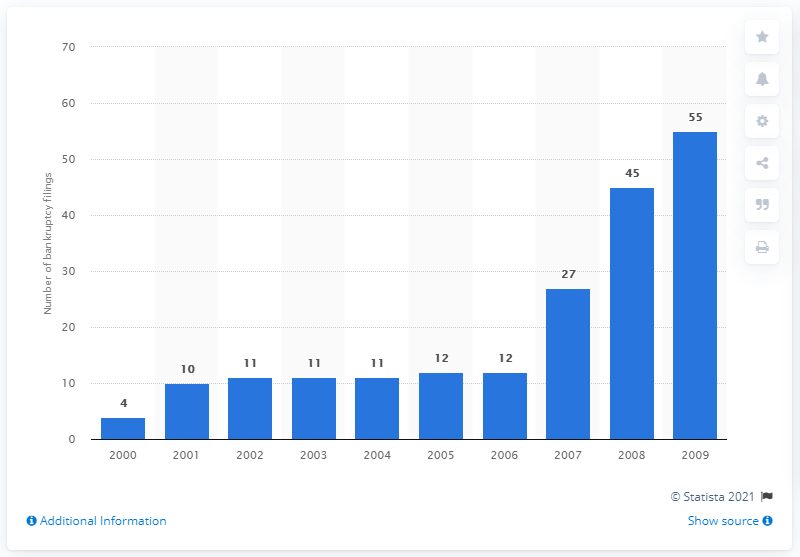Highlight a few significant elements in this photo. There were 12 chemical industry bankruptcy filings in 2006. In 2007, there were 27 chemical industry bankruptcy filings. There were 27 chemical industry bankruptcy filings in 2007. 